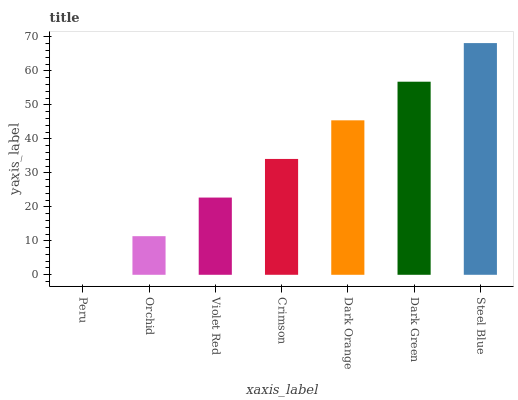Is Peru the minimum?
Answer yes or no. Yes. Is Steel Blue the maximum?
Answer yes or no. Yes. Is Orchid the minimum?
Answer yes or no. No. Is Orchid the maximum?
Answer yes or no. No. Is Orchid greater than Peru?
Answer yes or no. Yes. Is Peru less than Orchid?
Answer yes or no. Yes. Is Peru greater than Orchid?
Answer yes or no. No. Is Orchid less than Peru?
Answer yes or no. No. Is Crimson the high median?
Answer yes or no. Yes. Is Crimson the low median?
Answer yes or no. Yes. Is Dark Green the high median?
Answer yes or no. No. Is Peru the low median?
Answer yes or no. No. 